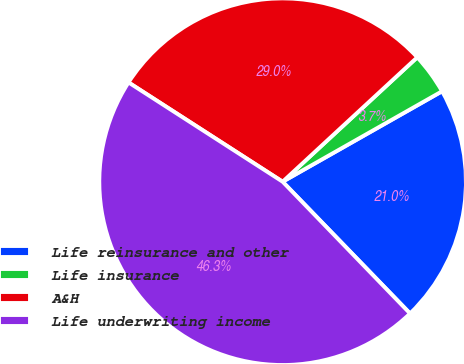<chart> <loc_0><loc_0><loc_500><loc_500><pie_chart><fcel>Life reinsurance and other<fcel>Life insurance<fcel>A&H<fcel>Life underwriting income<nl><fcel>20.98%<fcel>3.66%<fcel>29.02%<fcel>46.34%<nl></chart> 